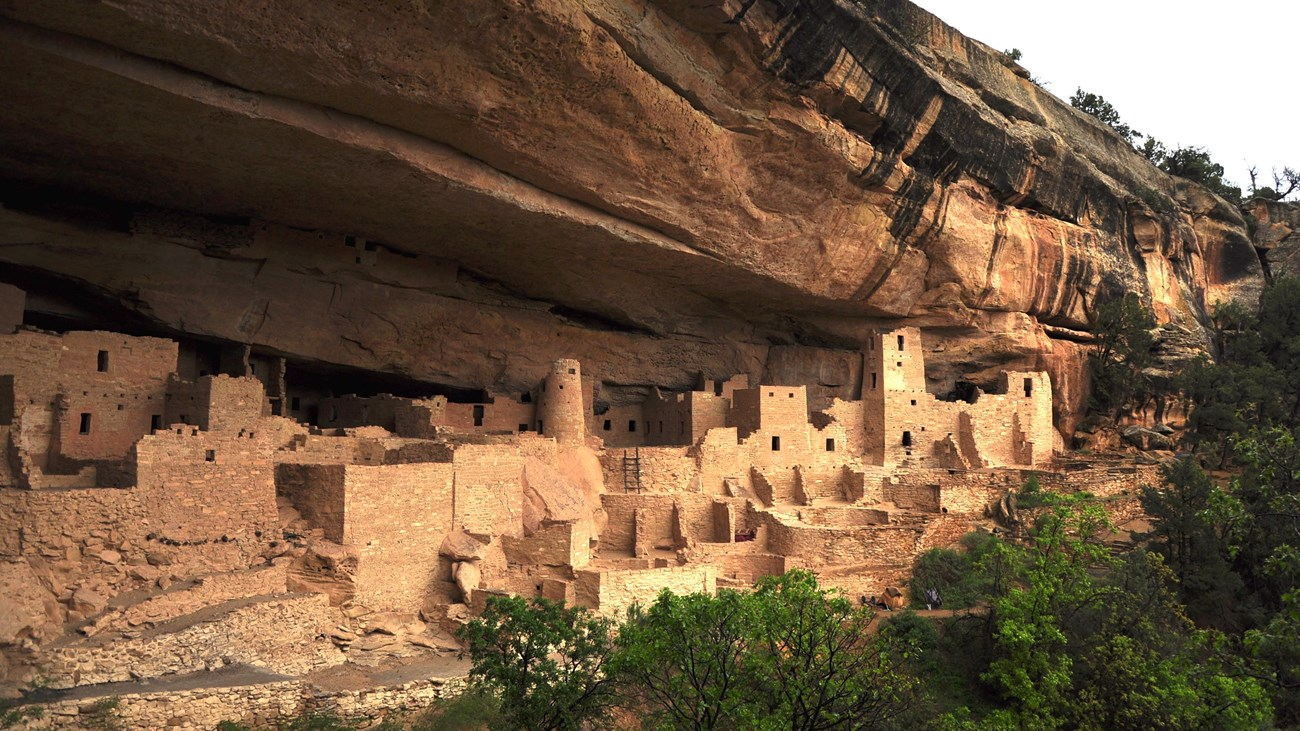If you could ask the ancient Puebloan people one question, what would it be? If I had the opportunity to ask the ancient Puebloan people one question, it would be: "What motivated and inspired you to build such elaborate and enduring cliff dwellings in this challenging landscape?" Understanding their vision, their connection to the land, and the cultural or spiritual reasons behind their architectural choices would provide deep insight into their way of life and the values that drove their extraordinary achievements. 